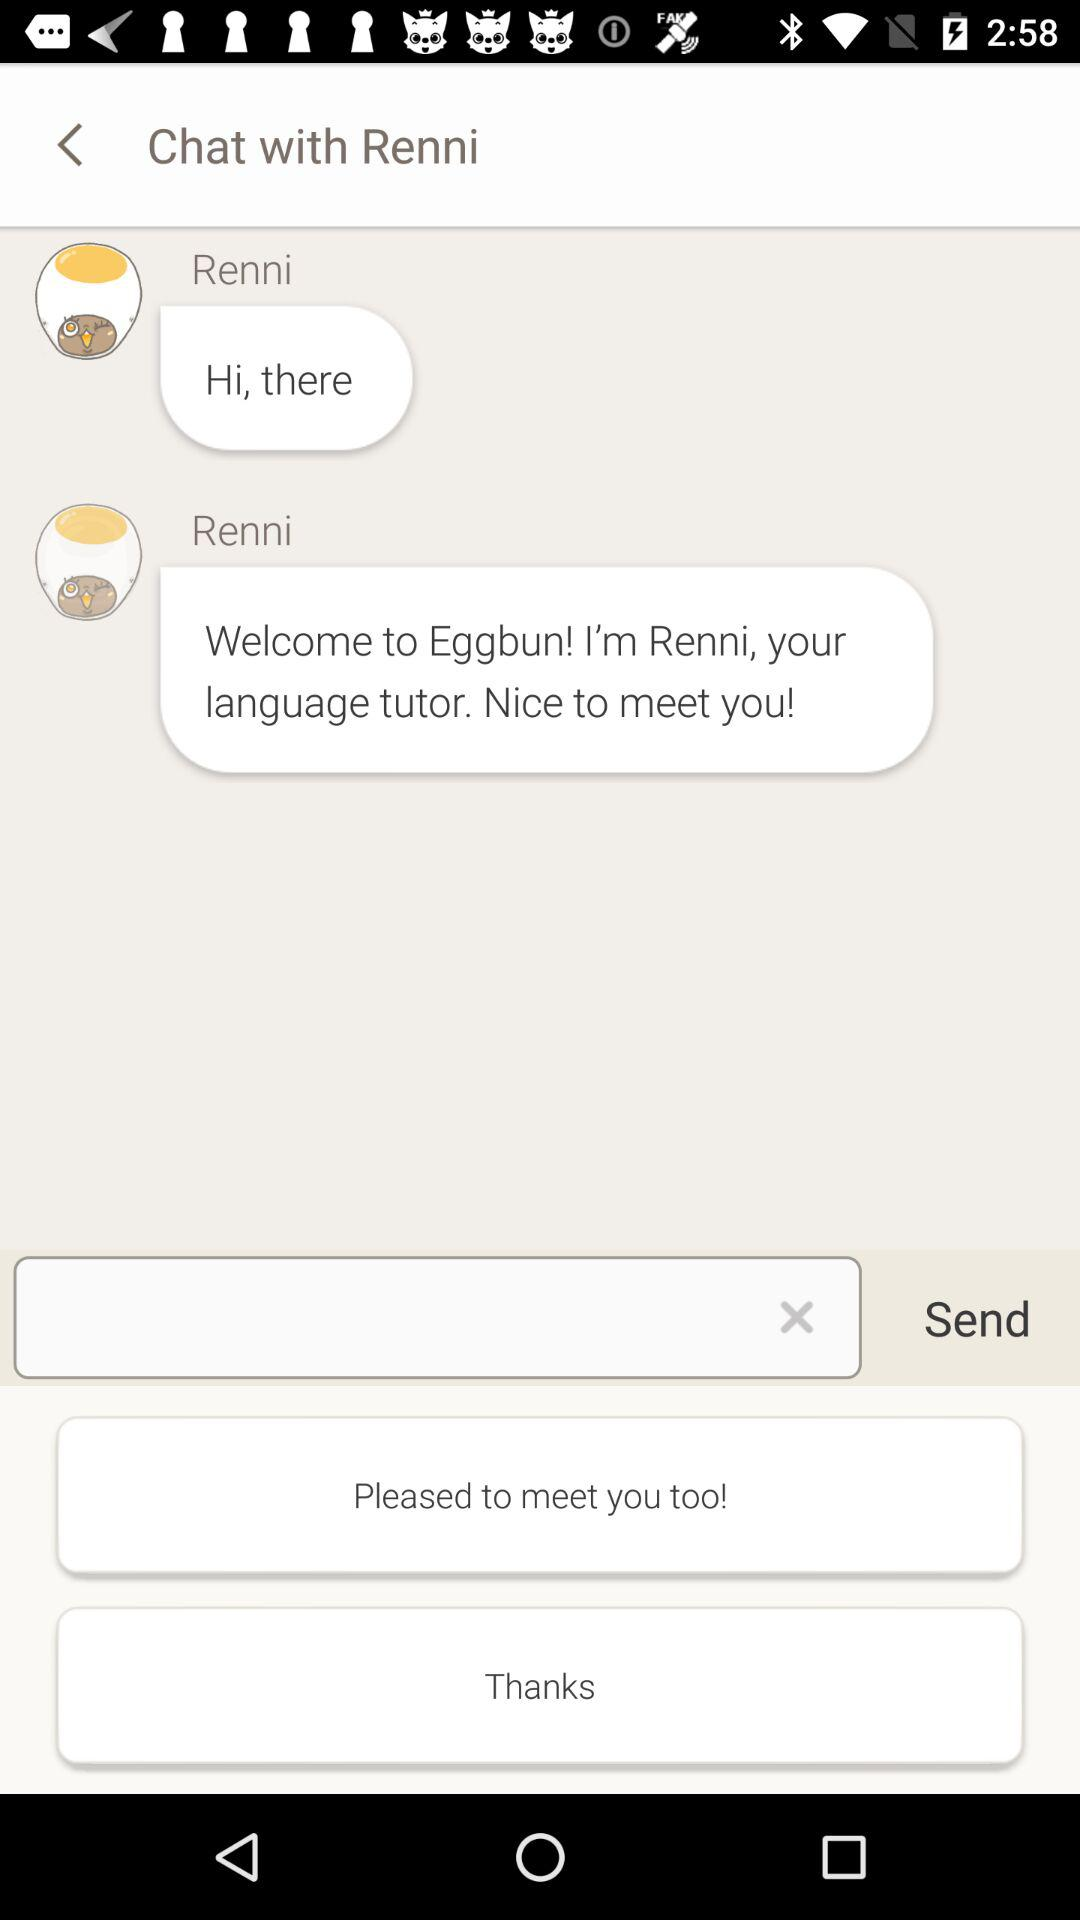What is the name of the person with whom chat is going on? The name of the person with whom chat is going on is Renni. 